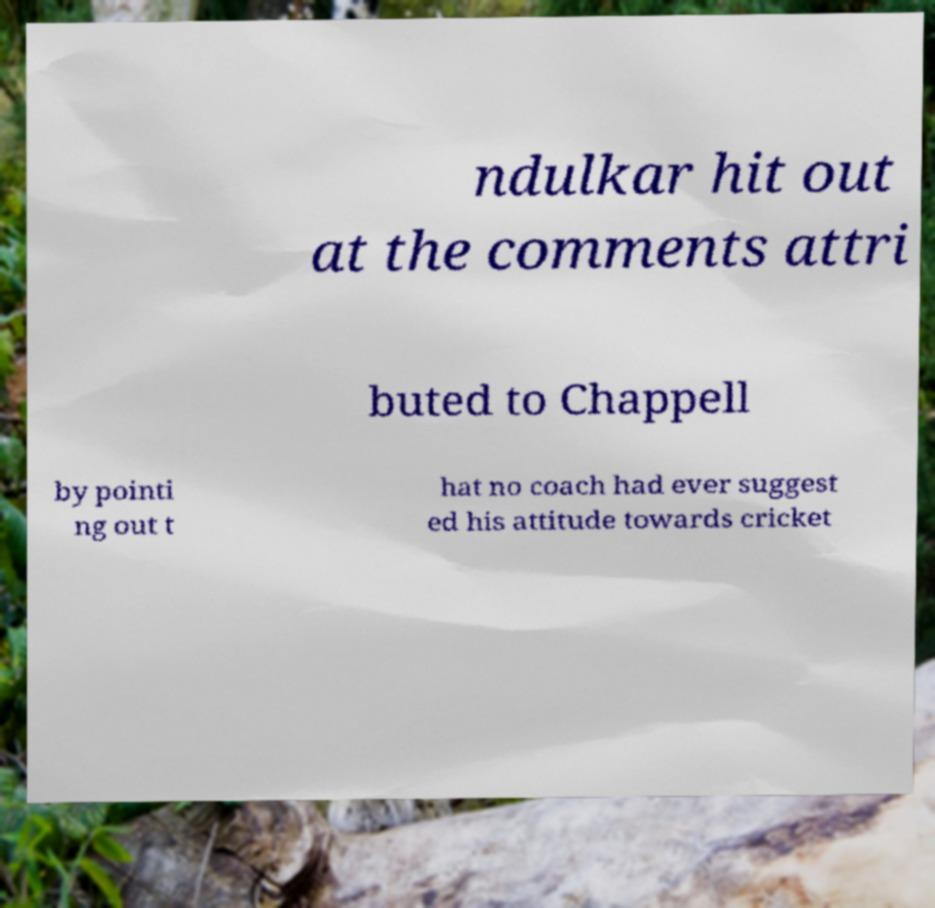Please read and relay the text visible in this image. What does it say? ndulkar hit out at the comments attri buted to Chappell by pointi ng out t hat no coach had ever suggest ed his attitude towards cricket 